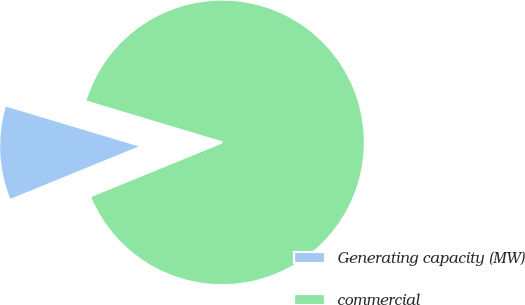<chart> <loc_0><loc_0><loc_500><loc_500><pie_chart><fcel>Generating capacity (MW)<fcel>commercial<nl><fcel>10.82%<fcel>89.18%<nl></chart> 